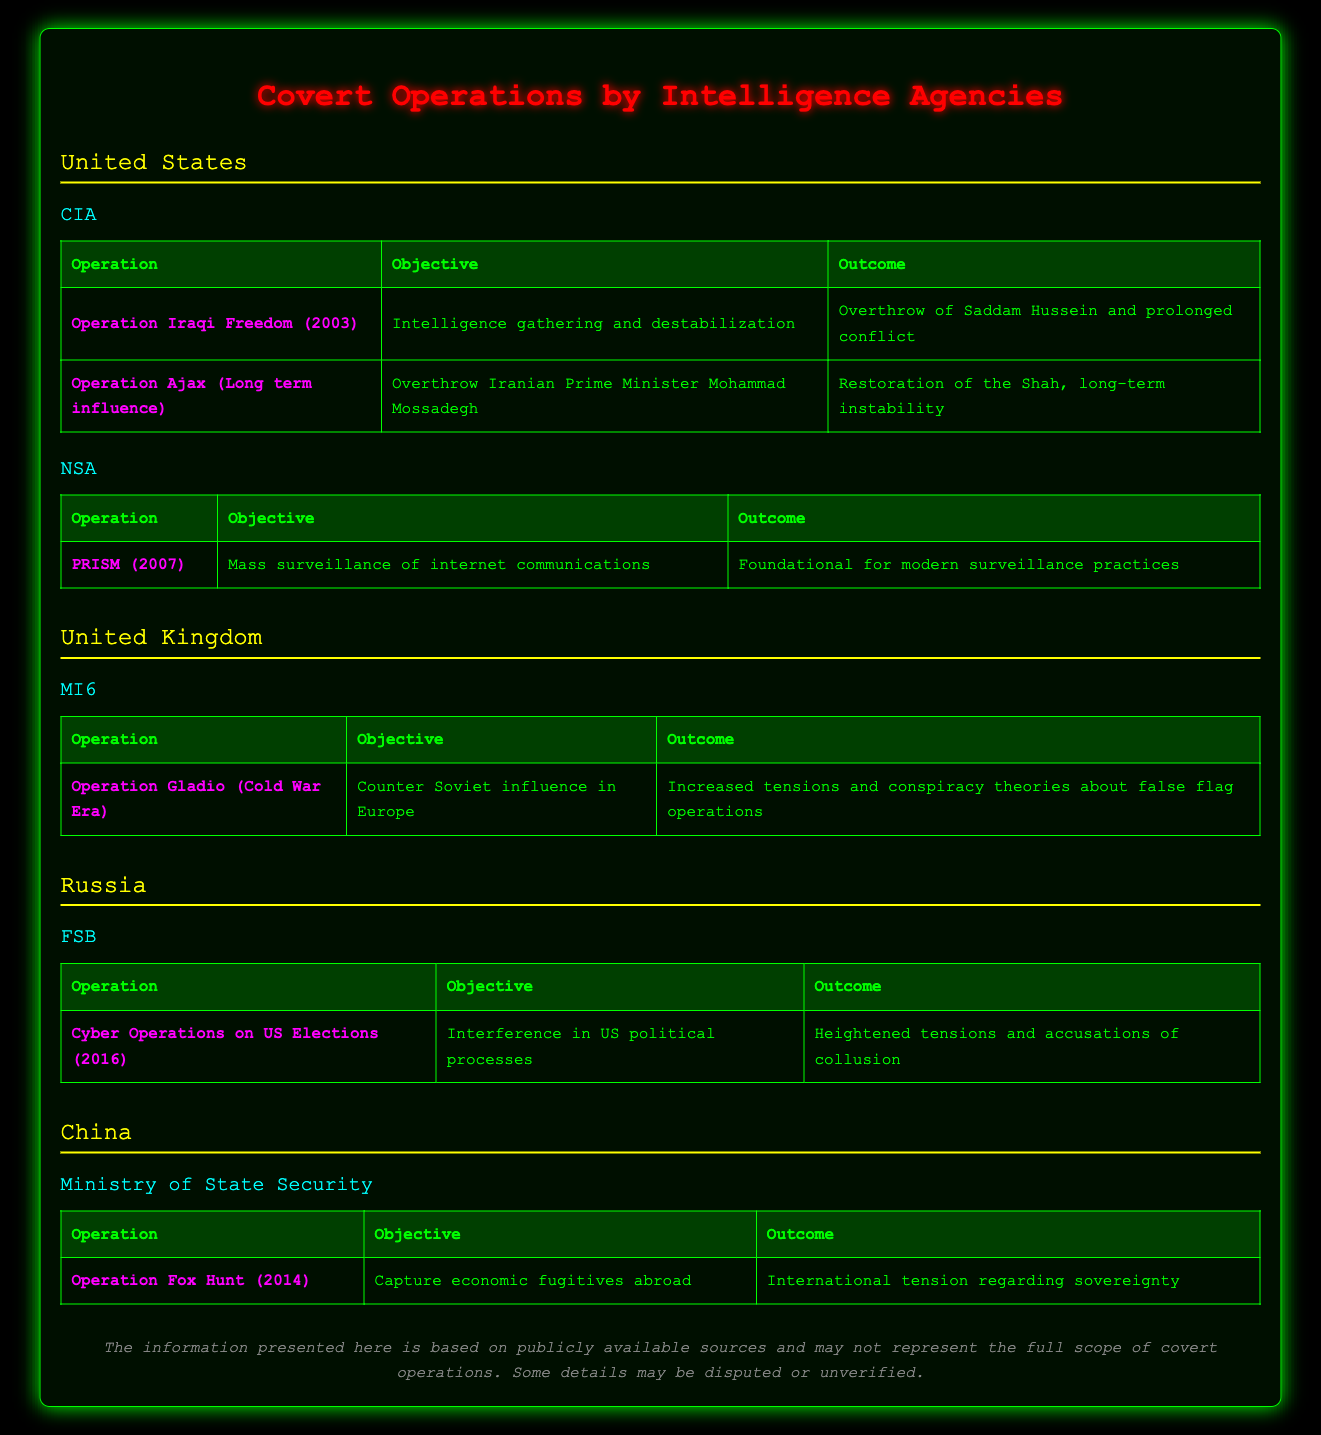What is the objective of Operation Ajax? The table lists the objective for Operation Ajax as "Overthrow Iranian Prime Minister Mohammad Mossadegh."
Answer: Overthrow Iranian Prime Minister Mohammad Mossadegh How many operations are listed under the CIA? The table shows two operations listed under the CIA: Operation Iraqi Freedom and Operation Ajax. Therefore, the total is 2.
Answer: 2 Did the NSA conduct any operations prior to 2010? The table shows only one NSA operation, PRISM, which took place in 2007; thus the statement is true.
Answer: Yes What were the outcomes of China's Operation Fox Hunt? According to the table, the outcome of Operation Fox Hunt is described as "International tension regarding sovereignty."
Answer: International tension regarding sovereignty Which agency conducted operations related to overthrowing a government? From the table, the CIA conducted operations aimed at government overthrowing, specifically Operation Iraqi Freedom and Operation Ajax.
Answer: CIA Which operation had an outcome related to "heightened tensions"? The operation that resulted in "Heightened tensions and accusations of collusion" is the Cyber Operations on US Elections conducted by the FSB in 2016.
Answer: Cyber Operations on US Elections (2016) How many countries are featured in the table with their intelligence agencies? The table presents covert operations from four countries: the United States, the United Kingdom, Russia, and China, making it a total of 4.
Answer: 4 What was the objective of the CIA's Operation Iraqi Freedom? The table specifies that the objective of Operation Iraqi Freedom is "Intelligence gathering and destabilization."
Answer: Intelligence gathering and destabilization Is it true that Operation Gladio was aimed at countering Soviet influence? The table explicitly states that the objective of Operation Gladio was "Counter Soviet influence in Europe," confirming the statement is true.
Answer: Yes 